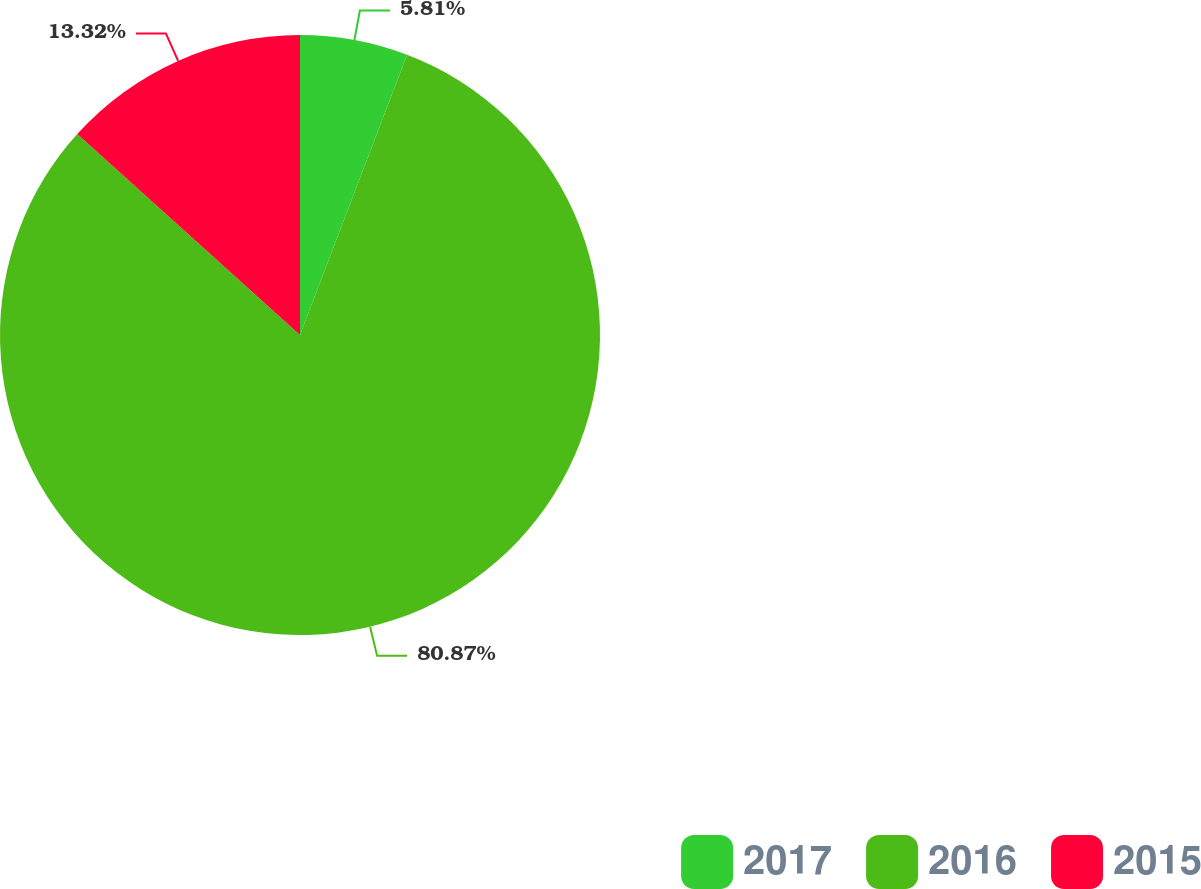Convert chart to OTSL. <chart><loc_0><loc_0><loc_500><loc_500><pie_chart><fcel>2017<fcel>2016<fcel>2015<nl><fcel>5.81%<fcel>80.88%<fcel>13.32%<nl></chart> 